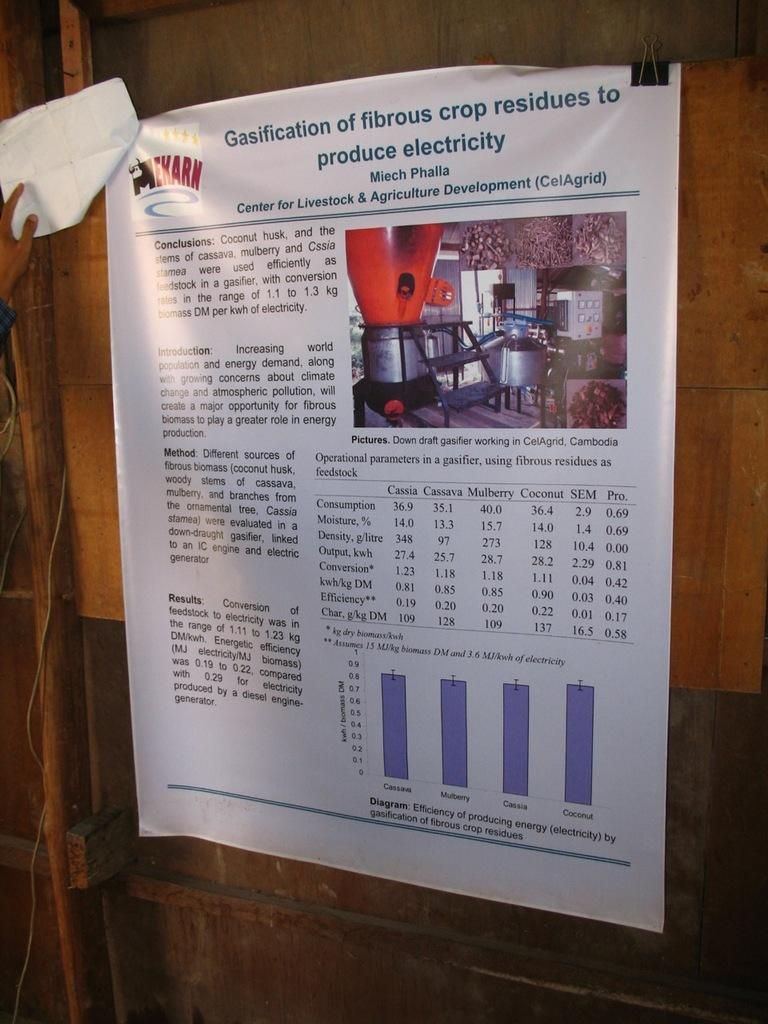<image>
Summarize the visual content of the image. A poster explaining making electricity from crop residue is on a wooden panel. 